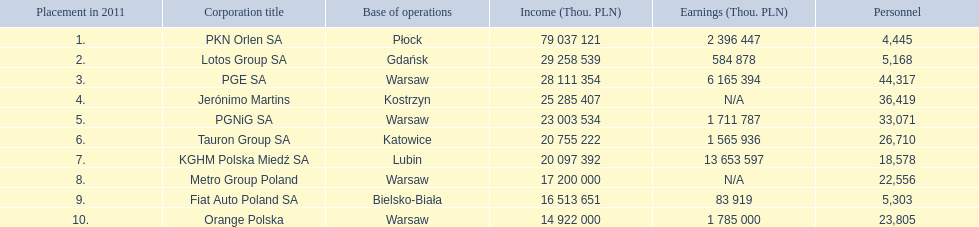Which company had the least revenue? Orange Polska. 